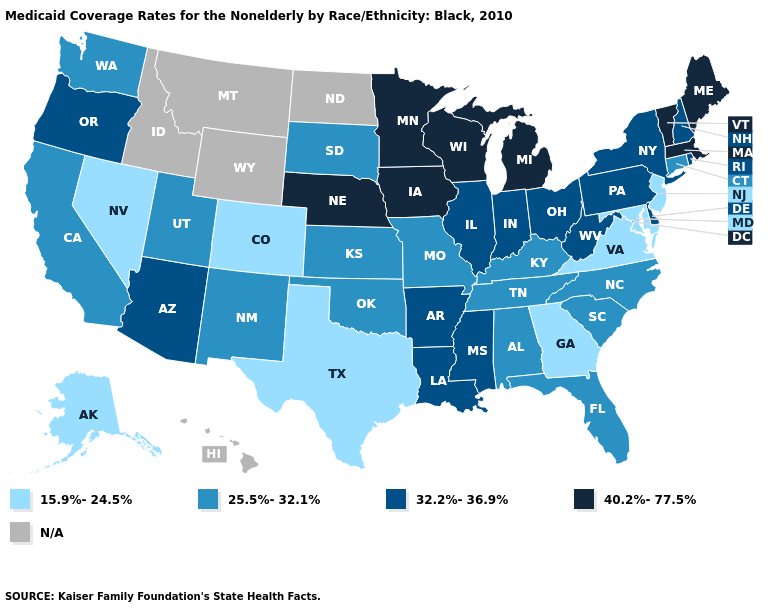Which states hav the highest value in the West?
Give a very brief answer. Arizona, Oregon. Does Maine have the highest value in the USA?
Quick response, please. Yes. What is the value of Connecticut?
Be succinct. 25.5%-32.1%. Name the states that have a value in the range 40.2%-77.5%?
Keep it brief. Iowa, Maine, Massachusetts, Michigan, Minnesota, Nebraska, Vermont, Wisconsin. What is the value of Texas?
Concise answer only. 15.9%-24.5%. Which states have the lowest value in the MidWest?
Answer briefly. Kansas, Missouri, South Dakota. Does Washington have the highest value in the West?
Answer briefly. No. Among the states that border Connecticut , which have the lowest value?
Give a very brief answer. New York, Rhode Island. Name the states that have a value in the range 40.2%-77.5%?
Answer briefly. Iowa, Maine, Massachusetts, Michigan, Minnesota, Nebraska, Vermont, Wisconsin. What is the highest value in states that border Washington?
Short answer required. 32.2%-36.9%. Name the states that have a value in the range 40.2%-77.5%?
Be succinct. Iowa, Maine, Massachusetts, Michigan, Minnesota, Nebraska, Vermont, Wisconsin. What is the value of Maryland?
Short answer required. 15.9%-24.5%. How many symbols are there in the legend?
Be succinct. 5. What is the lowest value in the USA?
Write a very short answer. 15.9%-24.5%. 